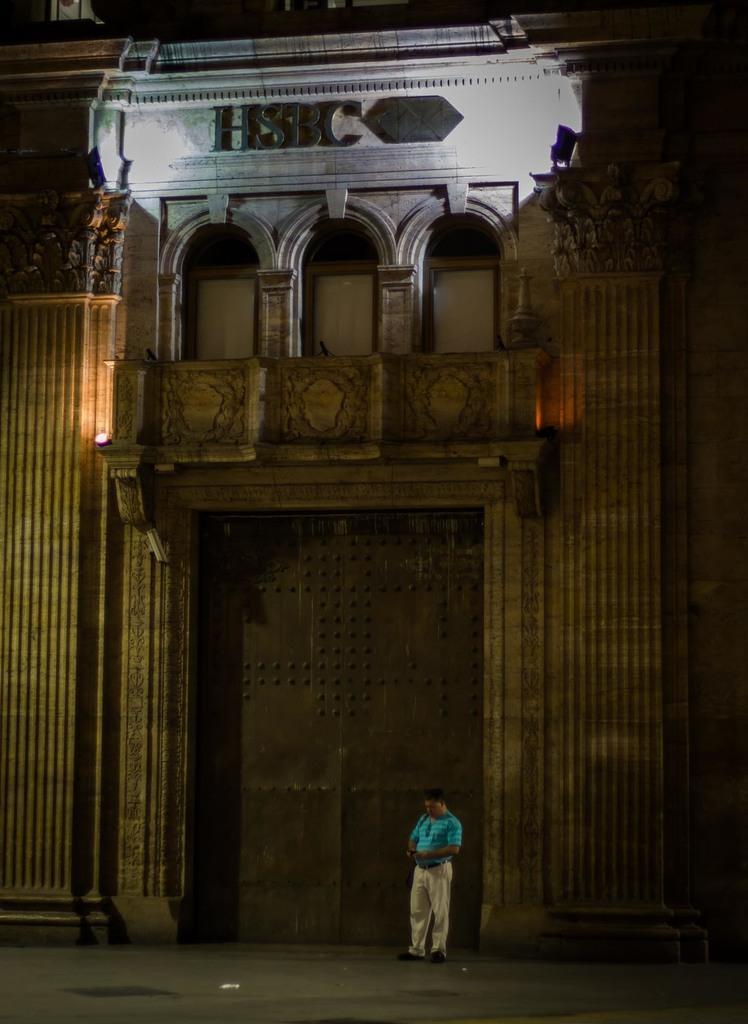Could you give a brief overview of what you see in this image? This picture is clicked outside. In the center there is a person wearing a blue color t-shirt and standing on the ground. In the background we can see the lights and we can see the building and the text on the building and we can see the gate and the windows of the building. 